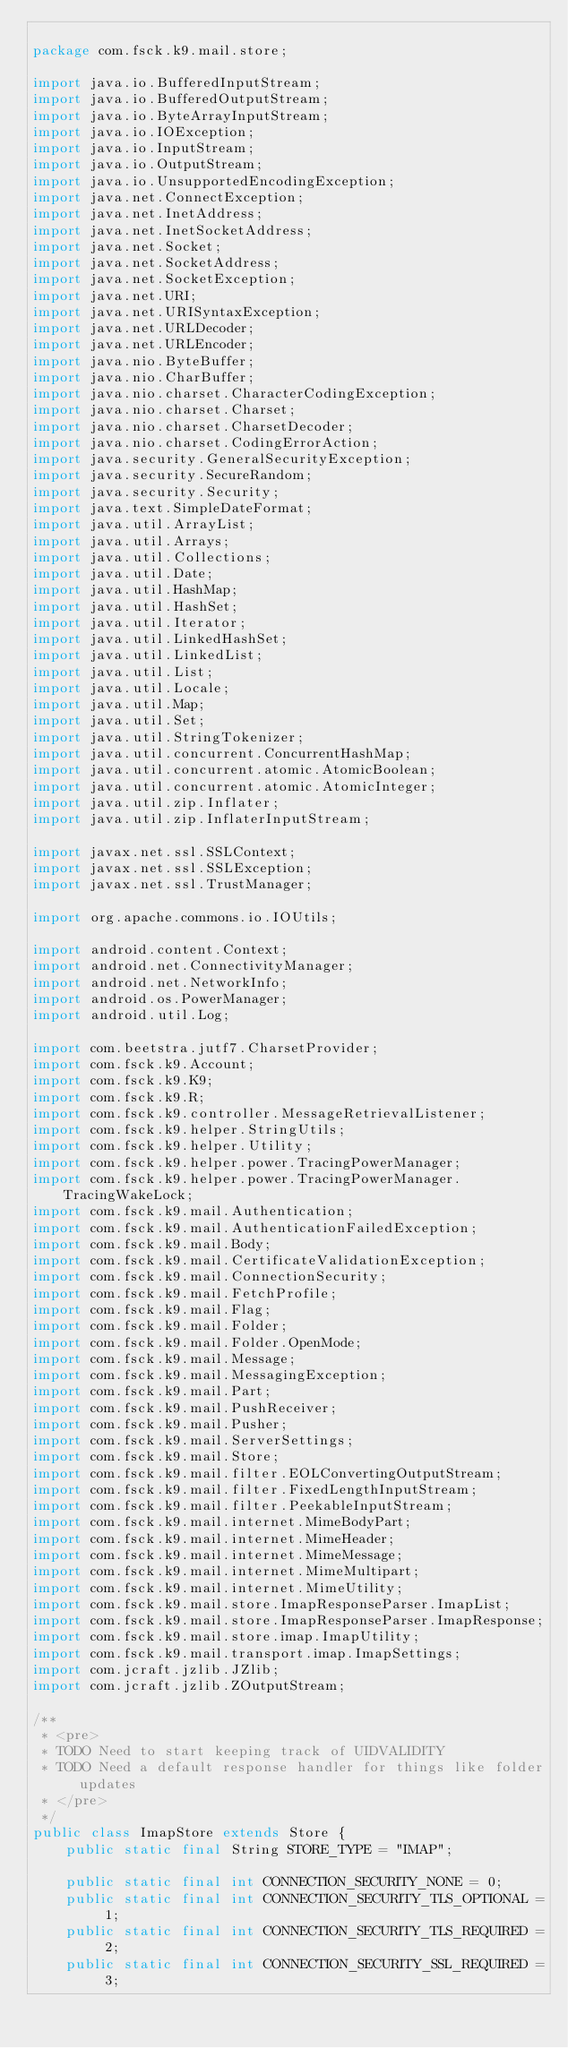<code> <loc_0><loc_0><loc_500><loc_500><_Java_>
package com.fsck.k9.mail.store;

import java.io.BufferedInputStream;
import java.io.BufferedOutputStream;
import java.io.ByteArrayInputStream;
import java.io.IOException;
import java.io.InputStream;
import java.io.OutputStream;
import java.io.UnsupportedEncodingException;
import java.net.ConnectException;
import java.net.InetAddress;
import java.net.InetSocketAddress;
import java.net.Socket;
import java.net.SocketAddress;
import java.net.SocketException;
import java.net.URI;
import java.net.URISyntaxException;
import java.net.URLDecoder;
import java.net.URLEncoder;
import java.nio.ByteBuffer;
import java.nio.CharBuffer;
import java.nio.charset.CharacterCodingException;
import java.nio.charset.Charset;
import java.nio.charset.CharsetDecoder;
import java.nio.charset.CodingErrorAction;
import java.security.GeneralSecurityException;
import java.security.SecureRandom;
import java.security.Security;
import java.text.SimpleDateFormat;
import java.util.ArrayList;
import java.util.Arrays;
import java.util.Collections;
import java.util.Date;
import java.util.HashMap;
import java.util.HashSet;
import java.util.Iterator;
import java.util.LinkedHashSet;
import java.util.LinkedList;
import java.util.List;
import java.util.Locale;
import java.util.Map;
import java.util.Set;
import java.util.StringTokenizer;
import java.util.concurrent.ConcurrentHashMap;
import java.util.concurrent.atomic.AtomicBoolean;
import java.util.concurrent.atomic.AtomicInteger;
import java.util.zip.Inflater;
import java.util.zip.InflaterInputStream;

import javax.net.ssl.SSLContext;
import javax.net.ssl.SSLException;
import javax.net.ssl.TrustManager;

import org.apache.commons.io.IOUtils;

import android.content.Context;
import android.net.ConnectivityManager;
import android.net.NetworkInfo;
import android.os.PowerManager;
import android.util.Log;

import com.beetstra.jutf7.CharsetProvider;
import com.fsck.k9.Account;
import com.fsck.k9.K9;
import com.fsck.k9.R;
import com.fsck.k9.controller.MessageRetrievalListener;
import com.fsck.k9.helper.StringUtils;
import com.fsck.k9.helper.Utility;
import com.fsck.k9.helper.power.TracingPowerManager;
import com.fsck.k9.helper.power.TracingPowerManager.TracingWakeLock;
import com.fsck.k9.mail.Authentication;
import com.fsck.k9.mail.AuthenticationFailedException;
import com.fsck.k9.mail.Body;
import com.fsck.k9.mail.CertificateValidationException;
import com.fsck.k9.mail.ConnectionSecurity;
import com.fsck.k9.mail.FetchProfile;
import com.fsck.k9.mail.Flag;
import com.fsck.k9.mail.Folder;
import com.fsck.k9.mail.Folder.OpenMode;
import com.fsck.k9.mail.Message;
import com.fsck.k9.mail.MessagingException;
import com.fsck.k9.mail.Part;
import com.fsck.k9.mail.PushReceiver;
import com.fsck.k9.mail.Pusher;
import com.fsck.k9.mail.ServerSettings;
import com.fsck.k9.mail.Store;
import com.fsck.k9.mail.filter.EOLConvertingOutputStream;
import com.fsck.k9.mail.filter.FixedLengthInputStream;
import com.fsck.k9.mail.filter.PeekableInputStream;
import com.fsck.k9.mail.internet.MimeBodyPart;
import com.fsck.k9.mail.internet.MimeHeader;
import com.fsck.k9.mail.internet.MimeMessage;
import com.fsck.k9.mail.internet.MimeMultipart;
import com.fsck.k9.mail.internet.MimeUtility;
import com.fsck.k9.mail.store.ImapResponseParser.ImapList;
import com.fsck.k9.mail.store.ImapResponseParser.ImapResponse;
import com.fsck.k9.mail.store.imap.ImapUtility;
import com.fsck.k9.mail.transport.imap.ImapSettings;
import com.jcraft.jzlib.JZlib;
import com.jcraft.jzlib.ZOutputStream;

/**
 * <pre>
 * TODO Need to start keeping track of UIDVALIDITY
 * TODO Need a default response handler for things like folder updates
 * </pre>
 */
public class ImapStore extends Store {
    public static final String STORE_TYPE = "IMAP";

    public static final int CONNECTION_SECURITY_NONE = 0;
    public static final int CONNECTION_SECURITY_TLS_OPTIONAL = 1;
    public static final int CONNECTION_SECURITY_TLS_REQUIRED = 2;
    public static final int CONNECTION_SECURITY_SSL_REQUIRED = 3;</code> 